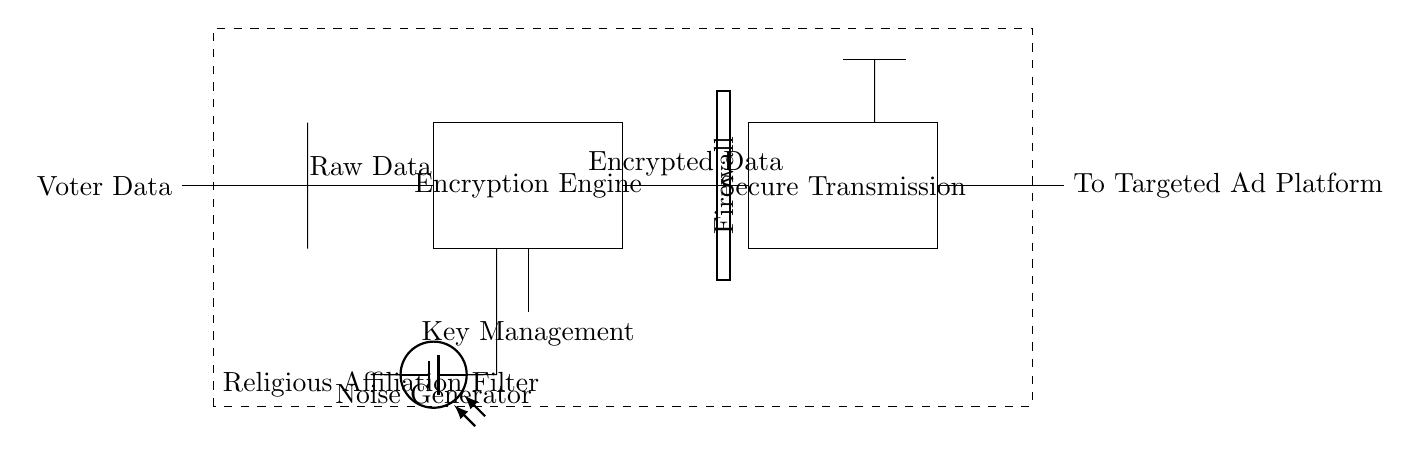What is the first component the circuit receives? The circuit receives "Voter Data" as the first input, which is indicated by the label on the left side of the diagram.
Answer: Voter Data What type of block is used to encrypt the data? The encryption block is labeled as "Encryption Engine," which is identified as a rectangular block in the diagram that processes raw data.
Answer: Encryption Engine What function does the noise generator serve in this circuit? The noise generator is intended to create noise that can simulate or protect against interference, which can impact the integrity of the data transmission.
Answer: Noise Generator What is located between the encryption engine and secure transmission? There is a "Firewall" positioned between the encryption engine and the secure transmission block. The firewall is designed to protect the data during transmission.
Answer: Firewall What is the purpose of the dashed rectangle in the circuit? The dashed rectangle indicates the "Religious Affiliation Filter," which suggests a filtering mechanism to target data based on religious affiliations.
Answer: Religious Affiliation Filter How is the encrypted data transmitted in the circuit? The encrypted data is transmitted through the "Secure Transmission" block, which follows the encryption engine in the diagram. This block indicates a secure means of sending data.
Answer: Secure Transmission 